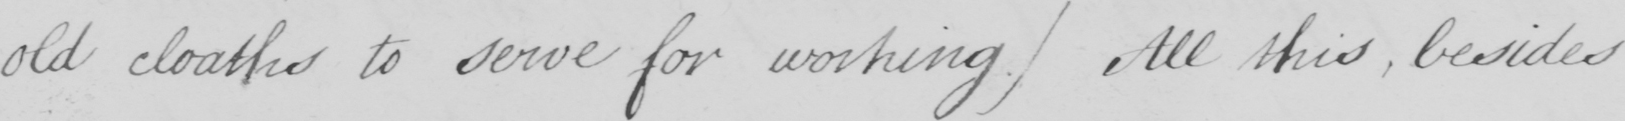Can you tell me what this handwritten text says? old cloaths to serve for working )  All this , besides 